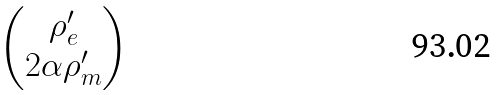Convert formula to latex. <formula><loc_0><loc_0><loc_500><loc_500>\begin{pmatrix} \rho _ { e } ^ { \prime } \\ 2 \alpha \rho _ { m } ^ { \prime } \end{pmatrix}</formula> 